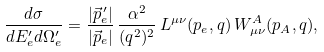Convert formula to latex. <formula><loc_0><loc_0><loc_500><loc_500>\frac { d \sigma } { d E _ { e } ^ { \prime } d \Omega _ { e } ^ { \prime } } = \frac { | \vec { p } _ { e } ^ { \, \prime } | } { | \vec { p } _ { e } | } \, \frac { \alpha ^ { 2 } } { ( q ^ { 2 } ) ^ { 2 } } \, L ^ { \mu \nu } ( p _ { e } , q ) \, W ^ { A } _ { \mu \nu } ( p _ { A } , q ) ,</formula> 